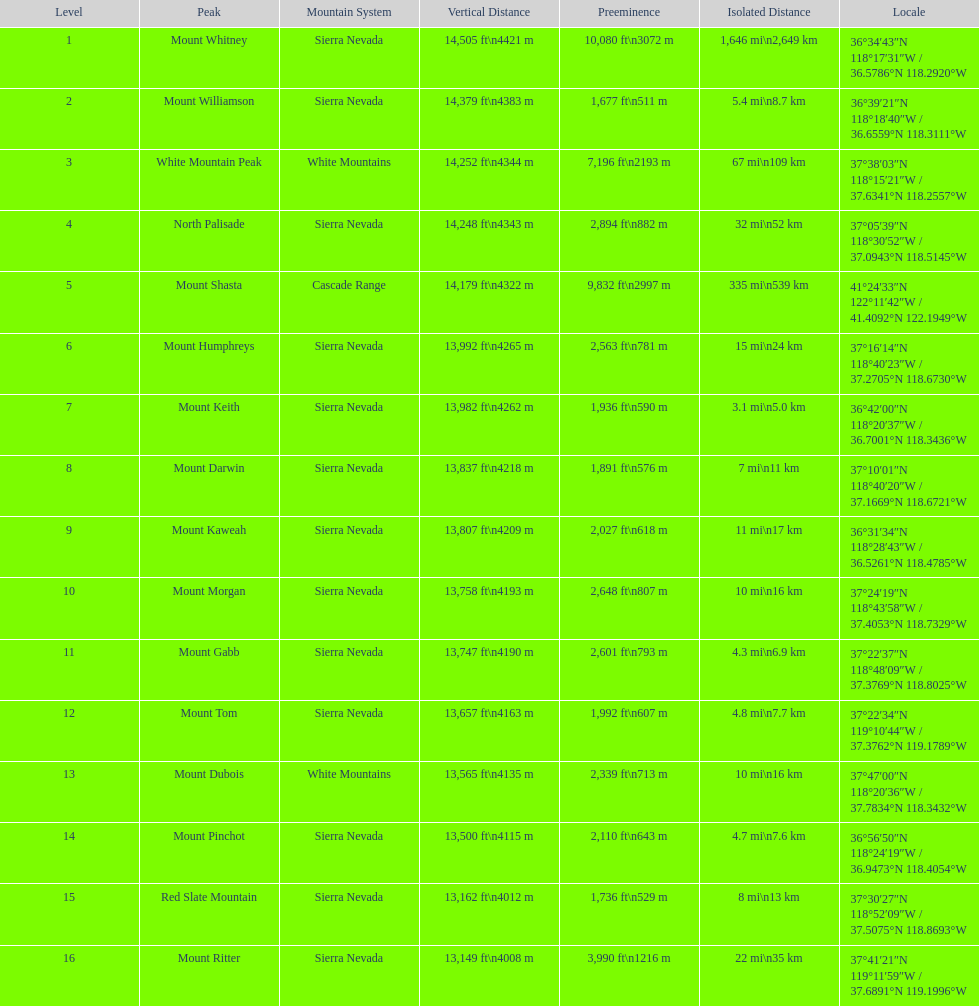Can you give me this table as a dict? {'header': ['Level', 'Peak', 'Mountain System', 'Vertical Distance', 'Preeminence', 'Isolated Distance', 'Locale'], 'rows': [['1', 'Mount Whitney', 'Sierra Nevada', '14,505\xa0ft\\n4421\xa0m', '10,080\xa0ft\\n3072\xa0m', '1,646\xa0mi\\n2,649\xa0km', '36°34′43″N 118°17′31″W\ufeff / \ufeff36.5786°N 118.2920°W'], ['2', 'Mount Williamson', 'Sierra Nevada', '14,379\xa0ft\\n4383\xa0m', '1,677\xa0ft\\n511\xa0m', '5.4\xa0mi\\n8.7\xa0km', '36°39′21″N 118°18′40″W\ufeff / \ufeff36.6559°N 118.3111°W'], ['3', 'White Mountain Peak', 'White Mountains', '14,252\xa0ft\\n4344\xa0m', '7,196\xa0ft\\n2193\xa0m', '67\xa0mi\\n109\xa0km', '37°38′03″N 118°15′21″W\ufeff / \ufeff37.6341°N 118.2557°W'], ['4', 'North Palisade', 'Sierra Nevada', '14,248\xa0ft\\n4343\xa0m', '2,894\xa0ft\\n882\xa0m', '32\xa0mi\\n52\xa0km', '37°05′39″N 118°30′52″W\ufeff / \ufeff37.0943°N 118.5145°W'], ['5', 'Mount Shasta', 'Cascade Range', '14,179\xa0ft\\n4322\xa0m', '9,832\xa0ft\\n2997\xa0m', '335\xa0mi\\n539\xa0km', '41°24′33″N 122°11′42″W\ufeff / \ufeff41.4092°N 122.1949°W'], ['6', 'Mount Humphreys', 'Sierra Nevada', '13,992\xa0ft\\n4265\xa0m', '2,563\xa0ft\\n781\xa0m', '15\xa0mi\\n24\xa0km', '37°16′14″N 118°40′23″W\ufeff / \ufeff37.2705°N 118.6730°W'], ['7', 'Mount Keith', 'Sierra Nevada', '13,982\xa0ft\\n4262\xa0m', '1,936\xa0ft\\n590\xa0m', '3.1\xa0mi\\n5.0\xa0km', '36°42′00″N 118°20′37″W\ufeff / \ufeff36.7001°N 118.3436°W'], ['8', 'Mount Darwin', 'Sierra Nevada', '13,837\xa0ft\\n4218\xa0m', '1,891\xa0ft\\n576\xa0m', '7\xa0mi\\n11\xa0km', '37°10′01″N 118°40′20″W\ufeff / \ufeff37.1669°N 118.6721°W'], ['9', 'Mount Kaweah', 'Sierra Nevada', '13,807\xa0ft\\n4209\xa0m', '2,027\xa0ft\\n618\xa0m', '11\xa0mi\\n17\xa0km', '36°31′34″N 118°28′43″W\ufeff / \ufeff36.5261°N 118.4785°W'], ['10', 'Mount Morgan', 'Sierra Nevada', '13,758\xa0ft\\n4193\xa0m', '2,648\xa0ft\\n807\xa0m', '10\xa0mi\\n16\xa0km', '37°24′19″N 118°43′58″W\ufeff / \ufeff37.4053°N 118.7329°W'], ['11', 'Mount Gabb', 'Sierra Nevada', '13,747\xa0ft\\n4190\xa0m', '2,601\xa0ft\\n793\xa0m', '4.3\xa0mi\\n6.9\xa0km', '37°22′37″N 118°48′09″W\ufeff / \ufeff37.3769°N 118.8025°W'], ['12', 'Mount Tom', 'Sierra Nevada', '13,657\xa0ft\\n4163\xa0m', '1,992\xa0ft\\n607\xa0m', '4.8\xa0mi\\n7.7\xa0km', '37°22′34″N 119°10′44″W\ufeff / \ufeff37.3762°N 119.1789°W'], ['13', 'Mount Dubois', 'White Mountains', '13,565\xa0ft\\n4135\xa0m', '2,339\xa0ft\\n713\xa0m', '10\xa0mi\\n16\xa0km', '37°47′00″N 118°20′36″W\ufeff / \ufeff37.7834°N 118.3432°W'], ['14', 'Mount Pinchot', 'Sierra Nevada', '13,500\xa0ft\\n4115\xa0m', '2,110\xa0ft\\n643\xa0m', '4.7\xa0mi\\n7.6\xa0km', '36°56′50″N 118°24′19″W\ufeff / \ufeff36.9473°N 118.4054°W'], ['15', 'Red Slate Mountain', 'Sierra Nevada', '13,162\xa0ft\\n4012\xa0m', '1,736\xa0ft\\n529\xa0m', '8\xa0mi\\n13\xa0km', '37°30′27″N 118°52′09″W\ufeff / \ufeff37.5075°N 118.8693°W'], ['16', 'Mount Ritter', 'Sierra Nevada', '13,149\xa0ft\\n4008\xa0m', '3,990\xa0ft\\n1216\xa0m', '22\xa0mi\\n35\xa0km', '37°41′21″N 119°11′59″W\ufeff / \ufeff37.6891°N 119.1996°W']]} Which mountain summit is the sole mountain summit in the cascade range? Mount Shasta. 